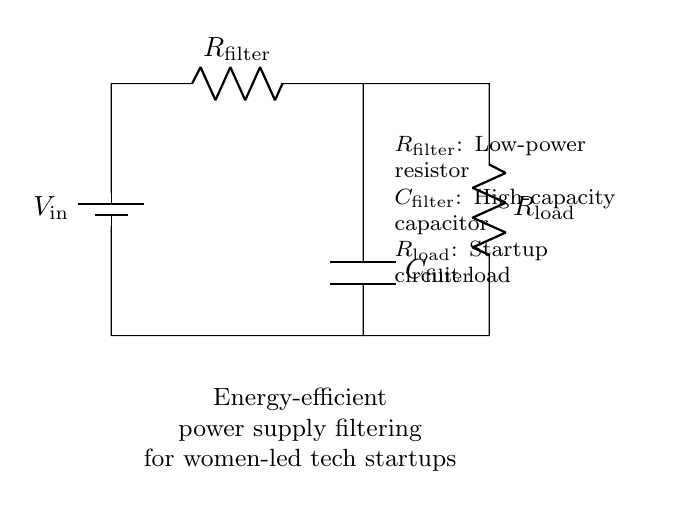What is the input voltage in the circuit? The circuit shows a battery labeled \( V_\text{in} \) connected to the input, indicating that it provides the input voltage for the circuit.
Answer: \( V_\text{in} \) What type of component is R_filter? R_filter is labeled on the circuit as a low-power resistor, which is a passive component used to limit current in the circuit.
Answer: Low-power resistor What is the role of C_filter in this circuit? C_filter is labeled as a high-capacity capacitor, which stores energy and smooths out voltage fluctuations in power supply filtering.
Answer: Energy storage What is the configuration of R_load with respect to C_filter? R_load is connected in parallel with C_filter in this circuit, meaning they share the same voltage across them.
Answer: Parallel configuration How does adding more capacitance to C_filter affect the circuit? Increasing the capacitance of C_filter would enhance voltage stability and reduce ripple in the output voltage by allowing the capacitor to store more energy for longer periods.
Answer: Improves stability What happens to the current flowing through R_filter when the load increases? When the load increases, the current through R_filter will increase as well since R_filter is part of a series circuit that feeds the load, increasing its thermal energy and potentially leading to heat generation.
Answer: Increases What is the purpose of filtering in this context? The purpose of filtering in this context is to provide a stable power supply by removing voltage variations and smoothing output currents for sensitive electronic circuits used in startups.
Answer: Voltage stabilization 